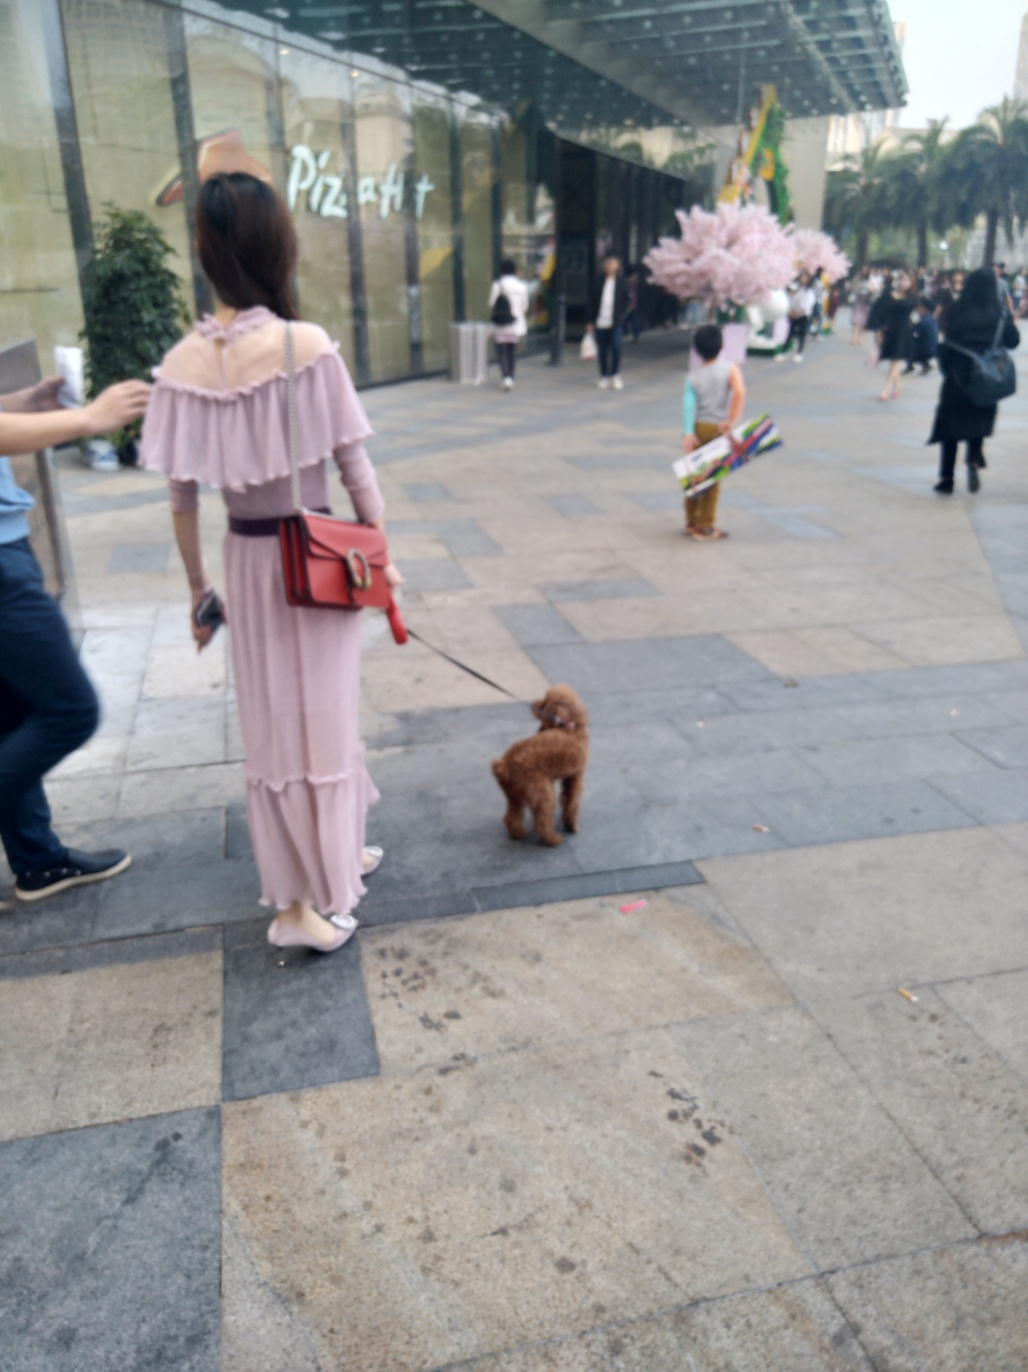Can you comment on the fashion style depicted in the image? Certainly, the image showcases contemporary casual fashion. The individual in the foreground is wearing a soft-hued, flowing dress complemented by a stylish hat and a bold red handbag, which adds a pop of color to the ensemble. The attire suggests a relaxed yet fashionable aesthetic that is well-suited for an urban setting and a leisurely stroll through the city. 